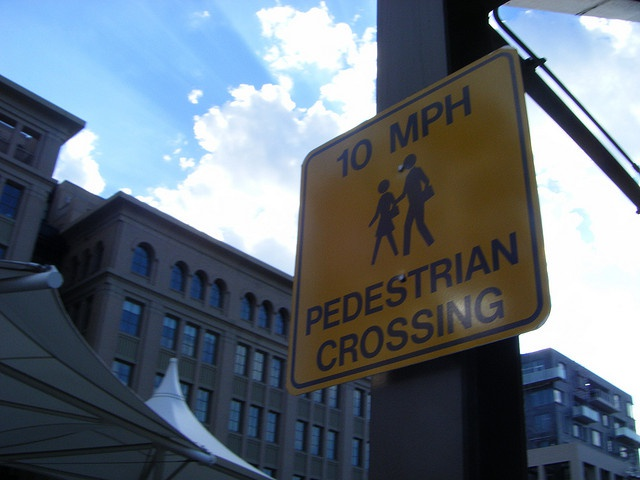Describe the objects in this image and their specific colors. I can see various objects in this image with different colors. 